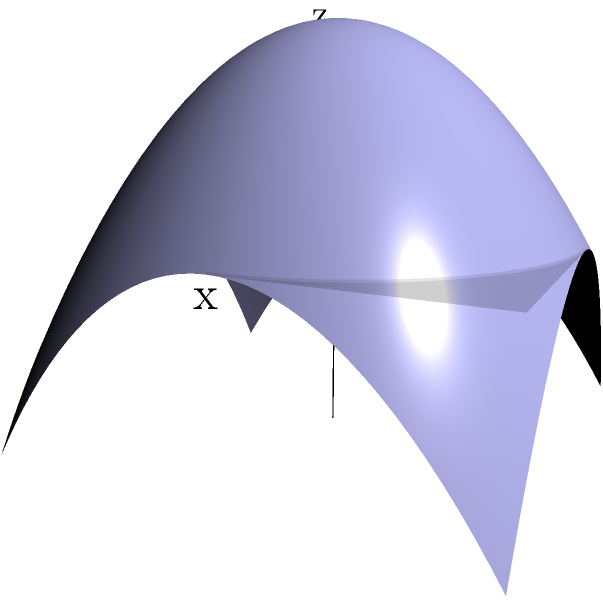In a racing game, you need to optimize the rendering of a curved road surface. The surface is approximated by the function $z = 1 - x^2 - y^2$ for $-1 \leq x,y \leq 1$. To reduce computational load, you decide to use a polygonal mesh. What is the minimum number of triangles needed to ensure that the maximum vertical error between the mesh and the actual surface is no more than 0.1 units? To solve this problem, we'll follow these steps:

1) The maximum vertical error occurs at the points furthest from the control points of the triangles. In a uniform grid, these points are at the center of each square formed by four control points.

2) Let's say we divide each side of the square $[-1,1] \times [-1,1]$ into $n$ equal parts. This creates a grid of $(n+1) \times (n+1)$ points, forming $2n^2$ triangles.

3) The length of each grid square is $2/n$.

4) The worst-case error will be at the center of a grid square. If $(x,y)$ is the center of a grid square, then:

   $|x| \leq 1/n$ and $|y| \leq 1/n$

5) The true height at this point is:

   $z = 1 - x^2 - y^2 \geq 1 - (1/n)^2 - (1/n)^2 = 1 - 2/n^2$

6) The approximated height at this point (assuming linear interpolation) is 1.

7) Therefore, the error is at most:

   $1 - (1 - 2/n^2) = 2/n^2$

8) We want this error to be no more than 0.1:

   $2/n^2 \leq 0.1$
   $n^2 \geq 20$
   $n \geq \sqrt{20} \approx 4.47$

9) Since $n$ must be an integer, we round up to $n = 5$.

10) The number of triangles is $2n^2 = 2(5^2) = 50$.

Therefore, we need at least 50 triangles to keep the maximum error below 0.1 units.
Answer: 50 triangles 